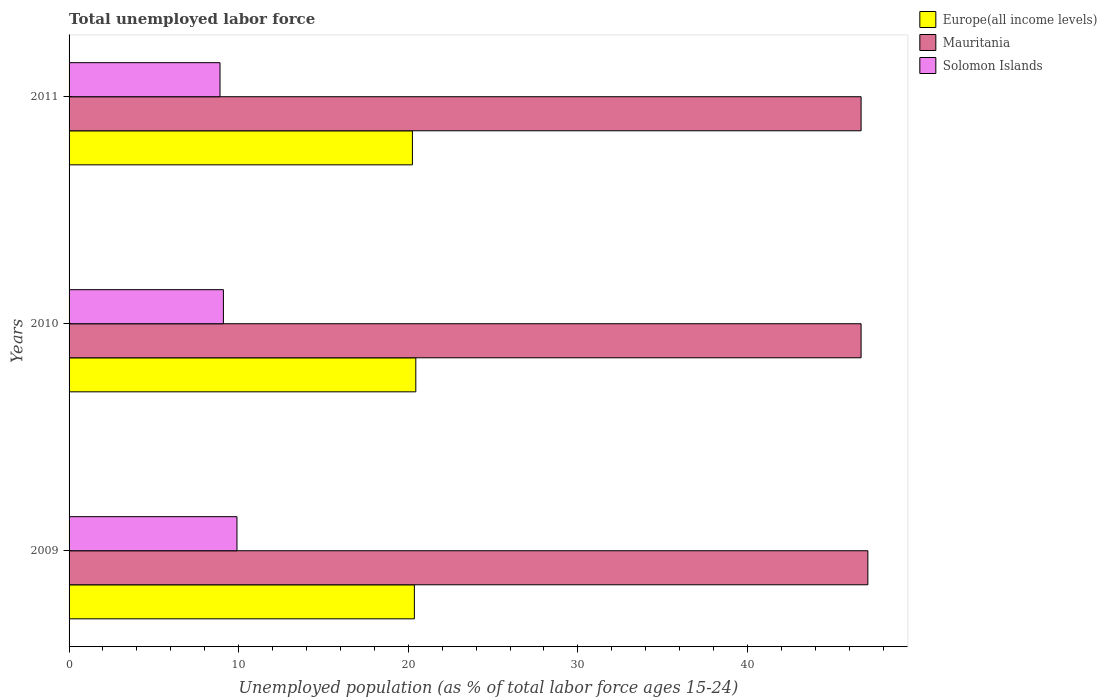How many different coloured bars are there?
Provide a succinct answer. 3. How many groups of bars are there?
Your response must be concise. 3. How many bars are there on the 1st tick from the top?
Your response must be concise. 3. How many bars are there on the 2nd tick from the bottom?
Offer a terse response. 3. In how many cases, is the number of bars for a given year not equal to the number of legend labels?
Your answer should be compact. 0. What is the percentage of unemployed population in in Mauritania in 2010?
Offer a terse response. 46.7. Across all years, what is the maximum percentage of unemployed population in in Europe(all income levels)?
Your response must be concise. 20.44. Across all years, what is the minimum percentage of unemployed population in in Europe(all income levels)?
Your response must be concise. 20.24. In which year was the percentage of unemployed population in in Europe(all income levels) maximum?
Your answer should be compact. 2010. In which year was the percentage of unemployed population in in Solomon Islands minimum?
Your answer should be compact. 2011. What is the total percentage of unemployed population in in Europe(all income levels) in the graph?
Offer a terse response. 61.05. What is the difference between the percentage of unemployed population in in Solomon Islands in 2010 and that in 2011?
Offer a very short reply. 0.2. What is the difference between the percentage of unemployed population in in Mauritania in 2010 and the percentage of unemployed population in in Europe(all income levels) in 2009?
Provide a short and direct response. 26.34. What is the average percentage of unemployed population in in Europe(all income levels) per year?
Give a very brief answer. 20.35. In the year 2011, what is the difference between the percentage of unemployed population in in Mauritania and percentage of unemployed population in in Europe(all income levels)?
Offer a terse response. 26.46. In how many years, is the percentage of unemployed population in in Europe(all income levels) greater than 44 %?
Offer a very short reply. 0. What is the ratio of the percentage of unemployed population in in Europe(all income levels) in 2009 to that in 2010?
Offer a terse response. 1. Is the difference between the percentage of unemployed population in in Mauritania in 2009 and 2010 greater than the difference between the percentage of unemployed population in in Europe(all income levels) in 2009 and 2010?
Your response must be concise. Yes. What is the difference between the highest and the second highest percentage of unemployed population in in Solomon Islands?
Make the answer very short. 0.8. What is the difference between the highest and the lowest percentage of unemployed population in in Mauritania?
Offer a terse response. 0.4. In how many years, is the percentage of unemployed population in in Mauritania greater than the average percentage of unemployed population in in Mauritania taken over all years?
Your answer should be very brief. 1. Is the sum of the percentage of unemployed population in in Mauritania in 2009 and 2010 greater than the maximum percentage of unemployed population in in Europe(all income levels) across all years?
Your response must be concise. Yes. What does the 3rd bar from the top in 2011 represents?
Your answer should be compact. Europe(all income levels). What does the 1st bar from the bottom in 2009 represents?
Provide a succinct answer. Europe(all income levels). Is it the case that in every year, the sum of the percentage of unemployed population in in Europe(all income levels) and percentage of unemployed population in in Solomon Islands is greater than the percentage of unemployed population in in Mauritania?
Keep it short and to the point. No. How many bars are there?
Keep it short and to the point. 9. Are all the bars in the graph horizontal?
Provide a short and direct response. Yes. How many years are there in the graph?
Provide a succinct answer. 3. What is the difference between two consecutive major ticks on the X-axis?
Provide a succinct answer. 10. Does the graph contain any zero values?
Give a very brief answer. No. How many legend labels are there?
Give a very brief answer. 3. How are the legend labels stacked?
Give a very brief answer. Vertical. What is the title of the graph?
Give a very brief answer. Total unemployed labor force. Does "Lithuania" appear as one of the legend labels in the graph?
Offer a terse response. No. What is the label or title of the X-axis?
Offer a very short reply. Unemployed population (as % of total labor force ages 15-24). What is the label or title of the Y-axis?
Make the answer very short. Years. What is the Unemployed population (as % of total labor force ages 15-24) in Europe(all income levels) in 2009?
Provide a short and direct response. 20.36. What is the Unemployed population (as % of total labor force ages 15-24) of Mauritania in 2009?
Ensure brevity in your answer.  47.1. What is the Unemployed population (as % of total labor force ages 15-24) in Solomon Islands in 2009?
Give a very brief answer. 9.9. What is the Unemployed population (as % of total labor force ages 15-24) of Europe(all income levels) in 2010?
Your answer should be compact. 20.44. What is the Unemployed population (as % of total labor force ages 15-24) of Mauritania in 2010?
Provide a succinct answer. 46.7. What is the Unemployed population (as % of total labor force ages 15-24) in Solomon Islands in 2010?
Offer a very short reply. 9.1. What is the Unemployed population (as % of total labor force ages 15-24) in Europe(all income levels) in 2011?
Give a very brief answer. 20.24. What is the Unemployed population (as % of total labor force ages 15-24) in Mauritania in 2011?
Make the answer very short. 46.7. What is the Unemployed population (as % of total labor force ages 15-24) in Solomon Islands in 2011?
Offer a terse response. 8.9. Across all years, what is the maximum Unemployed population (as % of total labor force ages 15-24) of Europe(all income levels)?
Ensure brevity in your answer.  20.44. Across all years, what is the maximum Unemployed population (as % of total labor force ages 15-24) of Mauritania?
Provide a succinct answer. 47.1. Across all years, what is the maximum Unemployed population (as % of total labor force ages 15-24) in Solomon Islands?
Provide a succinct answer. 9.9. Across all years, what is the minimum Unemployed population (as % of total labor force ages 15-24) of Europe(all income levels)?
Make the answer very short. 20.24. Across all years, what is the minimum Unemployed population (as % of total labor force ages 15-24) in Mauritania?
Your answer should be compact. 46.7. Across all years, what is the minimum Unemployed population (as % of total labor force ages 15-24) of Solomon Islands?
Your answer should be very brief. 8.9. What is the total Unemployed population (as % of total labor force ages 15-24) of Europe(all income levels) in the graph?
Provide a short and direct response. 61.05. What is the total Unemployed population (as % of total labor force ages 15-24) in Mauritania in the graph?
Offer a terse response. 140.5. What is the total Unemployed population (as % of total labor force ages 15-24) of Solomon Islands in the graph?
Ensure brevity in your answer.  27.9. What is the difference between the Unemployed population (as % of total labor force ages 15-24) in Europe(all income levels) in 2009 and that in 2010?
Your response must be concise. -0.08. What is the difference between the Unemployed population (as % of total labor force ages 15-24) of Europe(all income levels) in 2009 and that in 2011?
Provide a succinct answer. 0.12. What is the difference between the Unemployed population (as % of total labor force ages 15-24) in Europe(all income levels) in 2010 and that in 2011?
Give a very brief answer. 0.2. What is the difference between the Unemployed population (as % of total labor force ages 15-24) in Mauritania in 2010 and that in 2011?
Your answer should be compact. 0. What is the difference between the Unemployed population (as % of total labor force ages 15-24) of Europe(all income levels) in 2009 and the Unemployed population (as % of total labor force ages 15-24) of Mauritania in 2010?
Ensure brevity in your answer.  -26.34. What is the difference between the Unemployed population (as % of total labor force ages 15-24) in Europe(all income levels) in 2009 and the Unemployed population (as % of total labor force ages 15-24) in Solomon Islands in 2010?
Provide a short and direct response. 11.26. What is the difference between the Unemployed population (as % of total labor force ages 15-24) of Europe(all income levels) in 2009 and the Unemployed population (as % of total labor force ages 15-24) of Mauritania in 2011?
Keep it short and to the point. -26.34. What is the difference between the Unemployed population (as % of total labor force ages 15-24) of Europe(all income levels) in 2009 and the Unemployed population (as % of total labor force ages 15-24) of Solomon Islands in 2011?
Your answer should be compact. 11.46. What is the difference between the Unemployed population (as % of total labor force ages 15-24) in Mauritania in 2009 and the Unemployed population (as % of total labor force ages 15-24) in Solomon Islands in 2011?
Offer a terse response. 38.2. What is the difference between the Unemployed population (as % of total labor force ages 15-24) in Europe(all income levels) in 2010 and the Unemployed population (as % of total labor force ages 15-24) in Mauritania in 2011?
Make the answer very short. -26.26. What is the difference between the Unemployed population (as % of total labor force ages 15-24) of Europe(all income levels) in 2010 and the Unemployed population (as % of total labor force ages 15-24) of Solomon Islands in 2011?
Make the answer very short. 11.54. What is the difference between the Unemployed population (as % of total labor force ages 15-24) in Mauritania in 2010 and the Unemployed population (as % of total labor force ages 15-24) in Solomon Islands in 2011?
Ensure brevity in your answer.  37.8. What is the average Unemployed population (as % of total labor force ages 15-24) in Europe(all income levels) per year?
Your answer should be very brief. 20.35. What is the average Unemployed population (as % of total labor force ages 15-24) in Mauritania per year?
Keep it short and to the point. 46.83. In the year 2009, what is the difference between the Unemployed population (as % of total labor force ages 15-24) of Europe(all income levels) and Unemployed population (as % of total labor force ages 15-24) of Mauritania?
Make the answer very short. -26.74. In the year 2009, what is the difference between the Unemployed population (as % of total labor force ages 15-24) in Europe(all income levels) and Unemployed population (as % of total labor force ages 15-24) in Solomon Islands?
Your answer should be very brief. 10.46. In the year 2009, what is the difference between the Unemployed population (as % of total labor force ages 15-24) of Mauritania and Unemployed population (as % of total labor force ages 15-24) of Solomon Islands?
Give a very brief answer. 37.2. In the year 2010, what is the difference between the Unemployed population (as % of total labor force ages 15-24) of Europe(all income levels) and Unemployed population (as % of total labor force ages 15-24) of Mauritania?
Keep it short and to the point. -26.26. In the year 2010, what is the difference between the Unemployed population (as % of total labor force ages 15-24) of Europe(all income levels) and Unemployed population (as % of total labor force ages 15-24) of Solomon Islands?
Offer a very short reply. 11.34. In the year 2010, what is the difference between the Unemployed population (as % of total labor force ages 15-24) of Mauritania and Unemployed population (as % of total labor force ages 15-24) of Solomon Islands?
Give a very brief answer. 37.6. In the year 2011, what is the difference between the Unemployed population (as % of total labor force ages 15-24) of Europe(all income levels) and Unemployed population (as % of total labor force ages 15-24) of Mauritania?
Keep it short and to the point. -26.46. In the year 2011, what is the difference between the Unemployed population (as % of total labor force ages 15-24) of Europe(all income levels) and Unemployed population (as % of total labor force ages 15-24) of Solomon Islands?
Provide a short and direct response. 11.34. In the year 2011, what is the difference between the Unemployed population (as % of total labor force ages 15-24) in Mauritania and Unemployed population (as % of total labor force ages 15-24) in Solomon Islands?
Your answer should be very brief. 37.8. What is the ratio of the Unemployed population (as % of total labor force ages 15-24) in Mauritania in 2009 to that in 2010?
Provide a short and direct response. 1.01. What is the ratio of the Unemployed population (as % of total labor force ages 15-24) in Solomon Islands in 2009 to that in 2010?
Make the answer very short. 1.09. What is the ratio of the Unemployed population (as % of total labor force ages 15-24) in Europe(all income levels) in 2009 to that in 2011?
Keep it short and to the point. 1.01. What is the ratio of the Unemployed population (as % of total labor force ages 15-24) of Mauritania in 2009 to that in 2011?
Your answer should be compact. 1.01. What is the ratio of the Unemployed population (as % of total labor force ages 15-24) of Solomon Islands in 2009 to that in 2011?
Give a very brief answer. 1.11. What is the ratio of the Unemployed population (as % of total labor force ages 15-24) in Europe(all income levels) in 2010 to that in 2011?
Your answer should be compact. 1.01. What is the ratio of the Unemployed population (as % of total labor force ages 15-24) of Solomon Islands in 2010 to that in 2011?
Provide a succinct answer. 1.02. What is the difference between the highest and the second highest Unemployed population (as % of total labor force ages 15-24) of Europe(all income levels)?
Your answer should be compact. 0.08. What is the difference between the highest and the second highest Unemployed population (as % of total labor force ages 15-24) of Solomon Islands?
Your answer should be compact. 0.8. What is the difference between the highest and the lowest Unemployed population (as % of total labor force ages 15-24) in Europe(all income levels)?
Offer a very short reply. 0.2. 